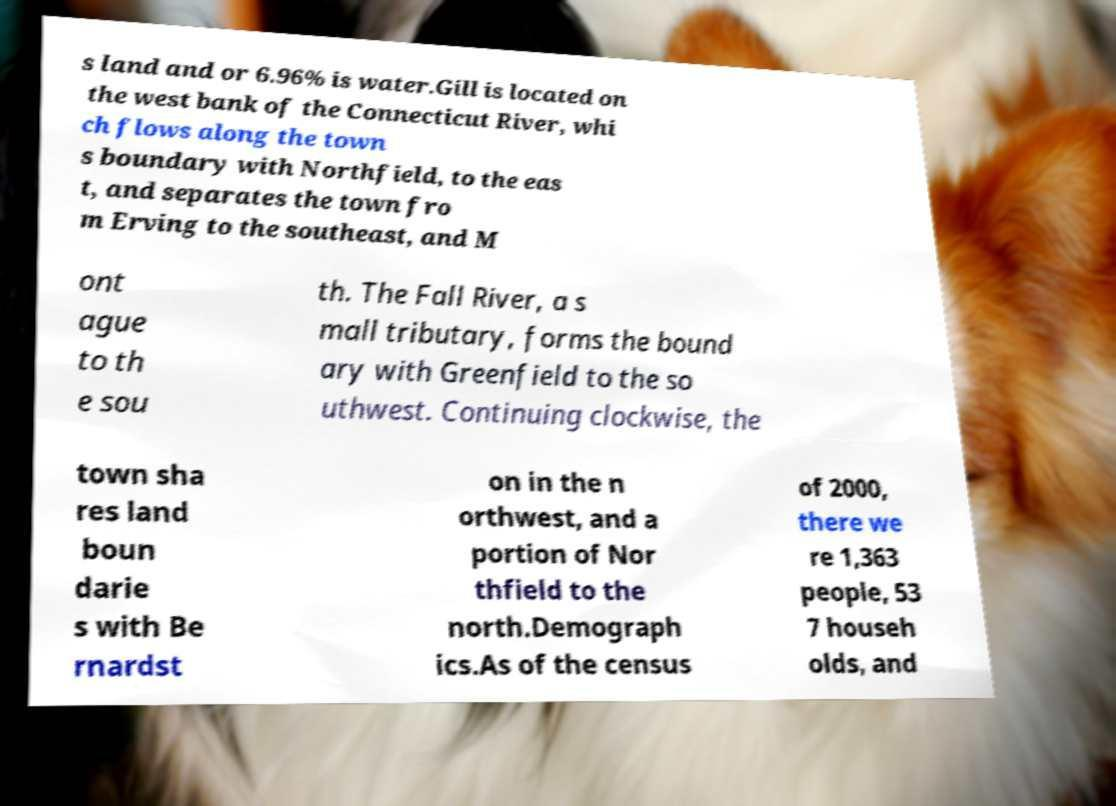Please read and relay the text visible in this image. What does it say? s land and or 6.96% is water.Gill is located on the west bank of the Connecticut River, whi ch flows along the town s boundary with Northfield, to the eas t, and separates the town fro m Erving to the southeast, and M ont ague to th e sou th. The Fall River, a s mall tributary, forms the bound ary with Greenfield to the so uthwest. Continuing clockwise, the town sha res land boun darie s with Be rnardst on in the n orthwest, and a portion of Nor thfield to the north.Demograph ics.As of the census of 2000, there we re 1,363 people, 53 7 househ olds, and 